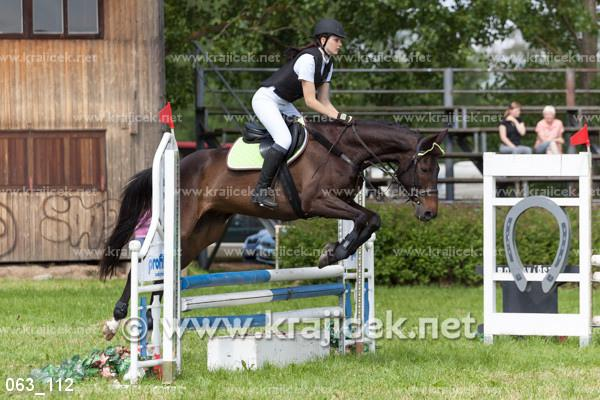What kind of horseback riding style is this? Please explain your reasoning. english. English horseback riding involves jumping. 